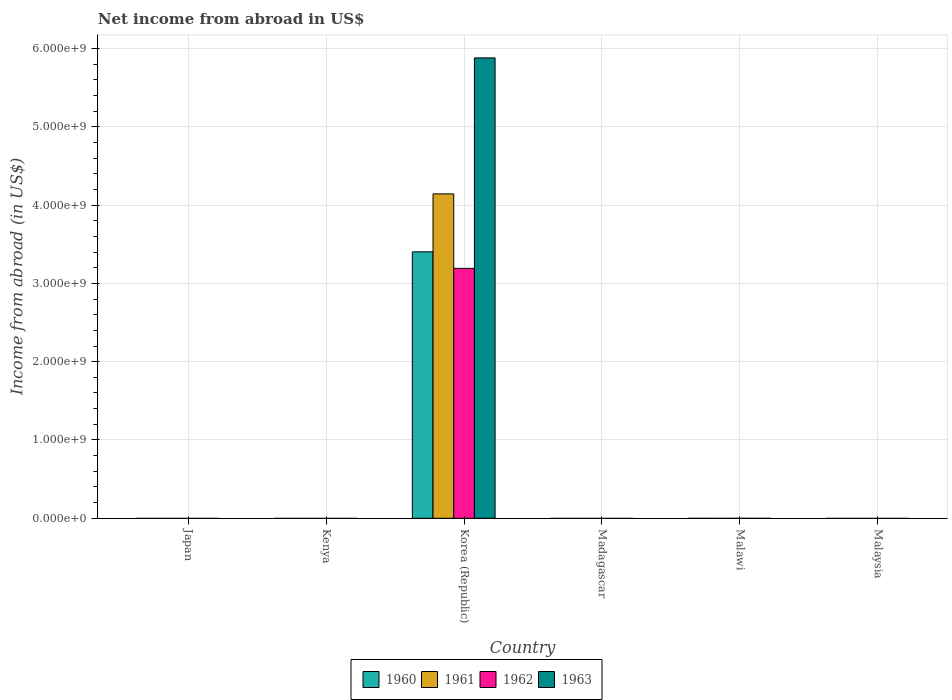How many different coloured bars are there?
Your answer should be compact. 4. Are the number of bars per tick equal to the number of legend labels?
Offer a very short reply. No. Are the number of bars on each tick of the X-axis equal?
Offer a very short reply. No. How many bars are there on the 3rd tick from the left?
Your response must be concise. 4. What is the label of the 4th group of bars from the left?
Ensure brevity in your answer.  Madagascar. In how many cases, is the number of bars for a given country not equal to the number of legend labels?
Provide a succinct answer. 5. What is the net income from abroad in 1961 in Malawi?
Make the answer very short. 0. Across all countries, what is the maximum net income from abroad in 1962?
Provide a succinct answer. 3.19e+09. Across all countries, what is the minimum net income from abroad in 1961?
Keep it short and to the point. 0. In which country was the net income from abroad in 1963 maximum?
Ensure brevity in your answer.  Korea (Republic). What is the total net income from abroad in 1963 in the graph?
Give a very brief answer. 5.88e+09. What is the difference between the net income from abroad in 1963 in Malaysia and the net income from abroad in 1961 in Madagascar?
Your answer should be compact. 0. What is the average net income from abroad in 1963 per country?
Your answer should be compact. 9.80e+08. In how many countries, is the net income from abroad in 1963 greater than 1200000000 US$?
Provide a succinct answer. 1. What is the difference between the highest and the lowest net income from abroad in 1960?
Your answer should be compact. 3.40e+09. Is it the case that in every country, the sum of the net income from abroad in 1960 and net income from abroad in 1963 is greater than the sum of net income from abroad in 1961 and net income from abroad in 1962?
Your answer should be very brief. No. Are all the bars in the graph horizontal?
Your response must be concise. No. How many countries are there in the graph?
Provide a short and direct response. 6. Does the graph contain any zero values?
Ensure brevity in your answer.  Yes. Where does the legend appear in the graph?
Your response must be concise. Bottom center. What is the title of the graph?
Ensure brevity in your answer.  Net income from abroad in US$. Does "1996" appear as one of the legend labels in the graph?
Keep it short and to the point. No. What is the label or title of the Y-axis?
Your answer should be very brief. Income from abroad (in US$). What is the Income from abroad (in US$) of 1962 in Japan?
Keep it short and to the point. 0. What is the Income from abroad (in US$) in 1963 in Japan?
Ensure brevity in your answer.  0. What is the Income from abroad (in US$) of 1961 in Kenya?
Your response must be concise. 0. What is the Income from abroad (in US$) in 1960 in Korea (Republic)?
Keep it short and to the point. 3.40e+09. What is the Income from abroad (in US$) of 1961 in Korea (Republic)?
Offer a very short reply. 4.14e+09. What is the Income from abroad (in US$) in 1962 in Korea (Republic)?
Your answer should be compact. 3.19e+09. What is the Income from abroad (in US$) of 1963 in Korea (Republic)?
Provide a short and direct response. 5.88e+09. What is the Income from abroad (in US$) of 1961 in Madagascar?
Keep it short and to the point. 0. What is the Income from abroad (in US$) in 1961 in Malawi?
Give a very brief answer. 0. What is the Income from abroad (in US$) of 1962 in Malawi?
Your answer should be very brief. 0. What is the Income from abroad (in US$) of 1963 in Malawi?
Your response must be concise. 0. What is the Income from abroad (in US$) of 1961 in Malaysia?
Give a very brief answer. 0. What is the Income from abroad (in US$) of 1963 in Malaysia?
Your answer should be very brief. 0. Across all countries, what is the maximum Income from abroad (in US$) in 1960?
Offer a very short reply. 3.40e+09. Across all countries, what is the maximum Income from abroad (in US$) of 1961?
Offer a terse response. 4.14e+09. Across all countries, what is the maximum Income from abroad (in US$) in 1962?
Make the answer very short. 3.19e+09. Across all countries, what is the maximum Income from abroad (in US$) in 1963?
Give a very brief answer. 5.88e+09. Across all countries, what is the minimum Income from abroad (in US$) in 1960?
Make the answer very short. 0. Across all countries, what is the minimum Income from abroad (in US$) in 1962?
Keep it short and to the point. 0. What is the total Income from abroad (in US$) of 1960 in the graph?
Provide a succinct answer. 3.40e+09. What is the total Income from abroad (in US$) of 1961 in the graph?
Your answer should be compact. 4.14e+09. What is the total Income from abroad (in US$) of 1962 in the graph?
Make the answer very short. 3.19e+09. What is the total Income from abroad (in US$) of 1963 in the graph?
Offer a very short reply. 5.88e+09. What is the average Income from abroad (in US$) of 1960 per country?
Your answer should be compact. 5.67e+08. What is the average Income from abroad (in US$) of 1961 per country?
Make the answer very short. 6.90e+08. What is the average Income from abroad (in US$) in 1962 per country?
Offer a very short reply. 5.32e+08. What is the average Income from abroad (in US$) of 1963 per country?
Offer a very short reply. 9.80e+08. What is the difference between the Income from abroad (in US$) in 1960 and Income from abroad (in US$) in 1961 in Korea (Republic)?
Your response must be concise. -7.40e+08. What is the difference between the Income from abroad (in US$) in 1960 and Income from abroad (in US$) in 1962 in Korea (Republic)?
Your answer should be compact. 2.11e+08. What is the difference between the Income from abroad (in US$) in 1960 and Income from abroad (in US$) in 1963 in Korea (Republic)?
Your response must be concise. -2.48e+09. What is the difference between the Income from abroad (in US$) in 1961 and Income from abroad (in US$) in 1962 in Korea (Republic)?
Your answer should be compact. 9.52e+08. What is the difference between the Income from abroad (in US$) in 1961 and Income from abroad (in US$) in 1963 in Korea (Republic)?
Ensure brevity in your answer.  -1.74e+09. What is the difference between the Income from abroad (in US$) of 1962 and Income from abroad (in US$) of 1963 in Korea (Republic)?
Offer a very short reply. -2.69e+09. What is the difference between the highest and the lowest Income from abroad (in US$) in 1960?
Give a very brief answer. 3.40e+09. What is the difference between the highest and the lowest Income from abroad (in US$) in 1961?
Your answer should be very brief. 4.14e+09. What is the difference between the highest and the lowest Income from abroad (in US$) in 1962?
Provide a short and direct response. 3.19e+09. What is the difference between the highest and the lowest Income from abroad (in US$) in 1963?
Make the answer very short. 5.88e+09. 